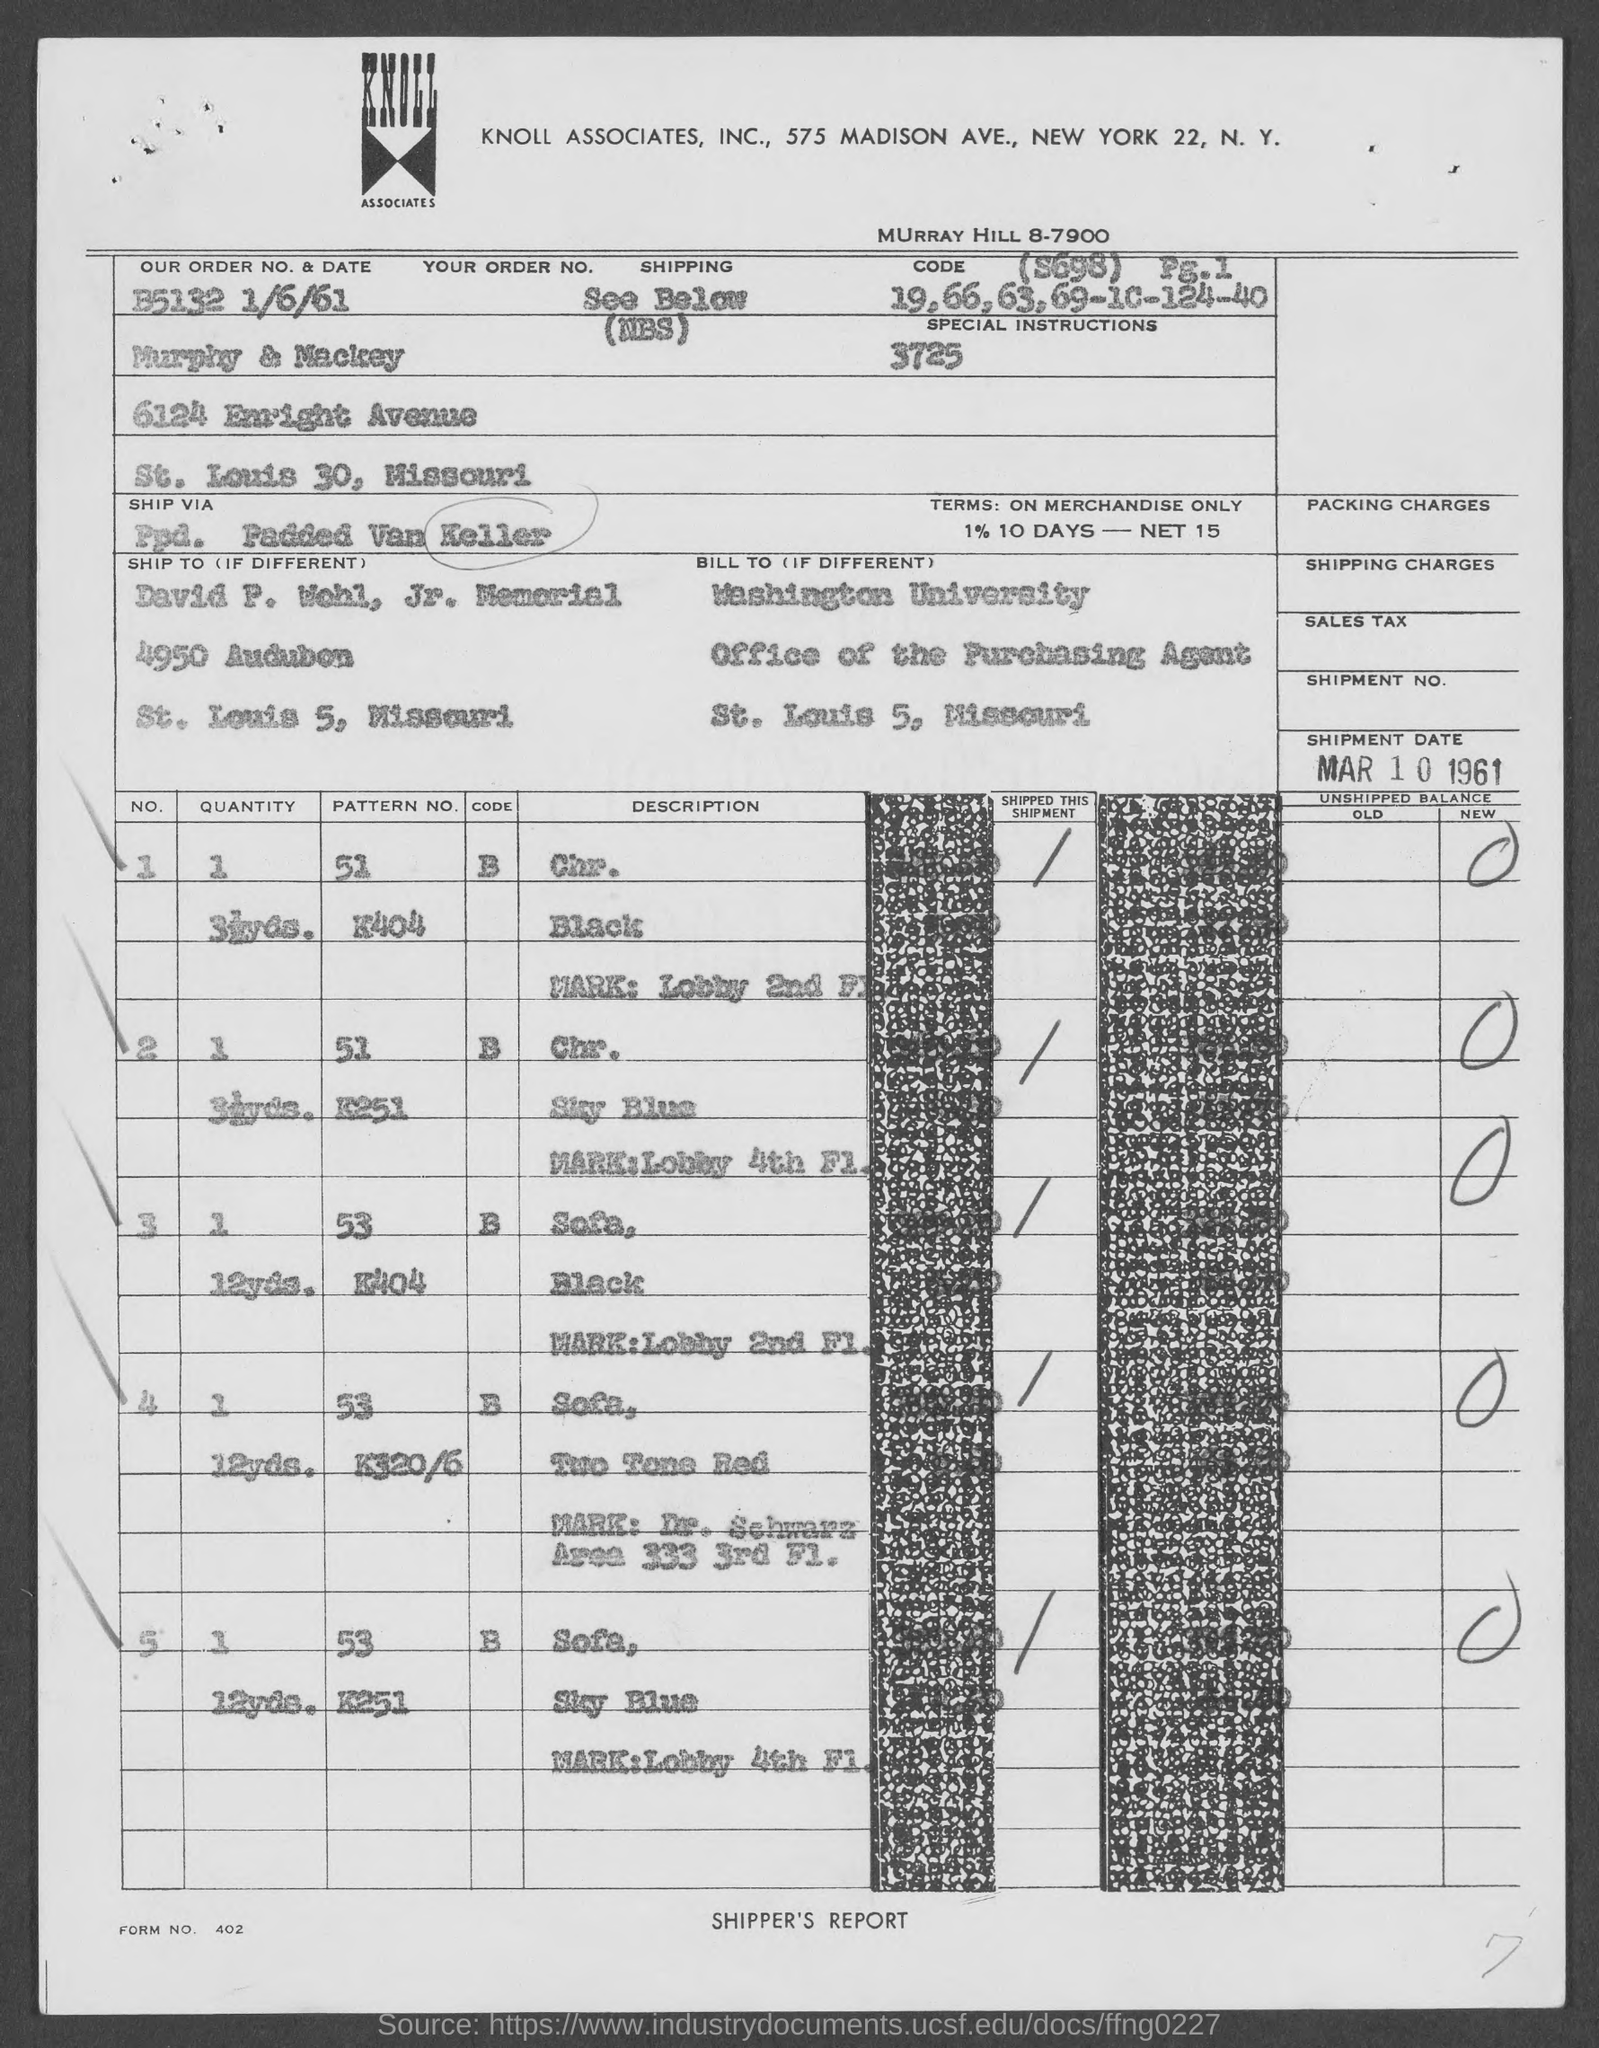When is the shipment date?
Your answer should be very brief. Mar 10 1961. What is our order no.?
Your answer should be compact. B5132 1/6/61. What is form no. ?
Make the answer very short. 402. 